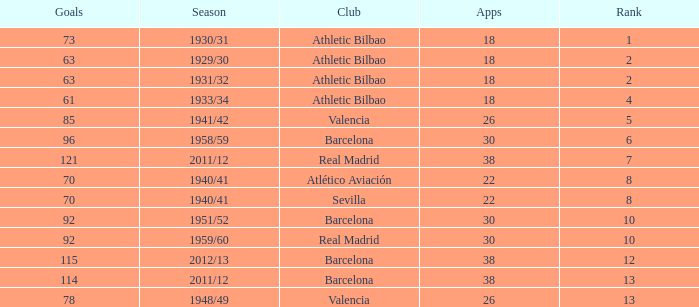What season was Barcelona ranked higher than 12, had more than 96 goals and had more than 26 apps? 2011/12. Can you parse all the data within this table? {'header': ['Goals', 'Season', 'Club', 'Apps', 'Rank'], 'rows': [['73', '1930/31', 'Athletic Bilbao', '18', '1'], ['63', '1929/30', 'Athletic Bilbao', '18', '2'], ['63', '1931/32', 'Athletic Bilbao', '18', '2'], ['61', '1933/34', 'Athletic Bilbao', '18', '4'], ['85', '1941/42', 'Valencia', '26', '5'], ['96', '1958/59', 'Barcelona', '30', '6'], ['121', '2011/12', 'Real Madrid', '38', '7'], ['70', '1940/41', 'Atlético Aviación', '22', '8'], ['70', '1940/41', 'Sevilla', '22', '8'], ['92', '1951/52', 'Barcelona', '30', '10'], ['92', '1959/60', 'Real Madrid', '30', '10'], ['115', '2012/13', 'Barcelona', '38', '12'], ['114', '2011/12', 'Barcelona', '38', '13'], ['78', '1948/49', 'Valencia', '26', '13']]} 